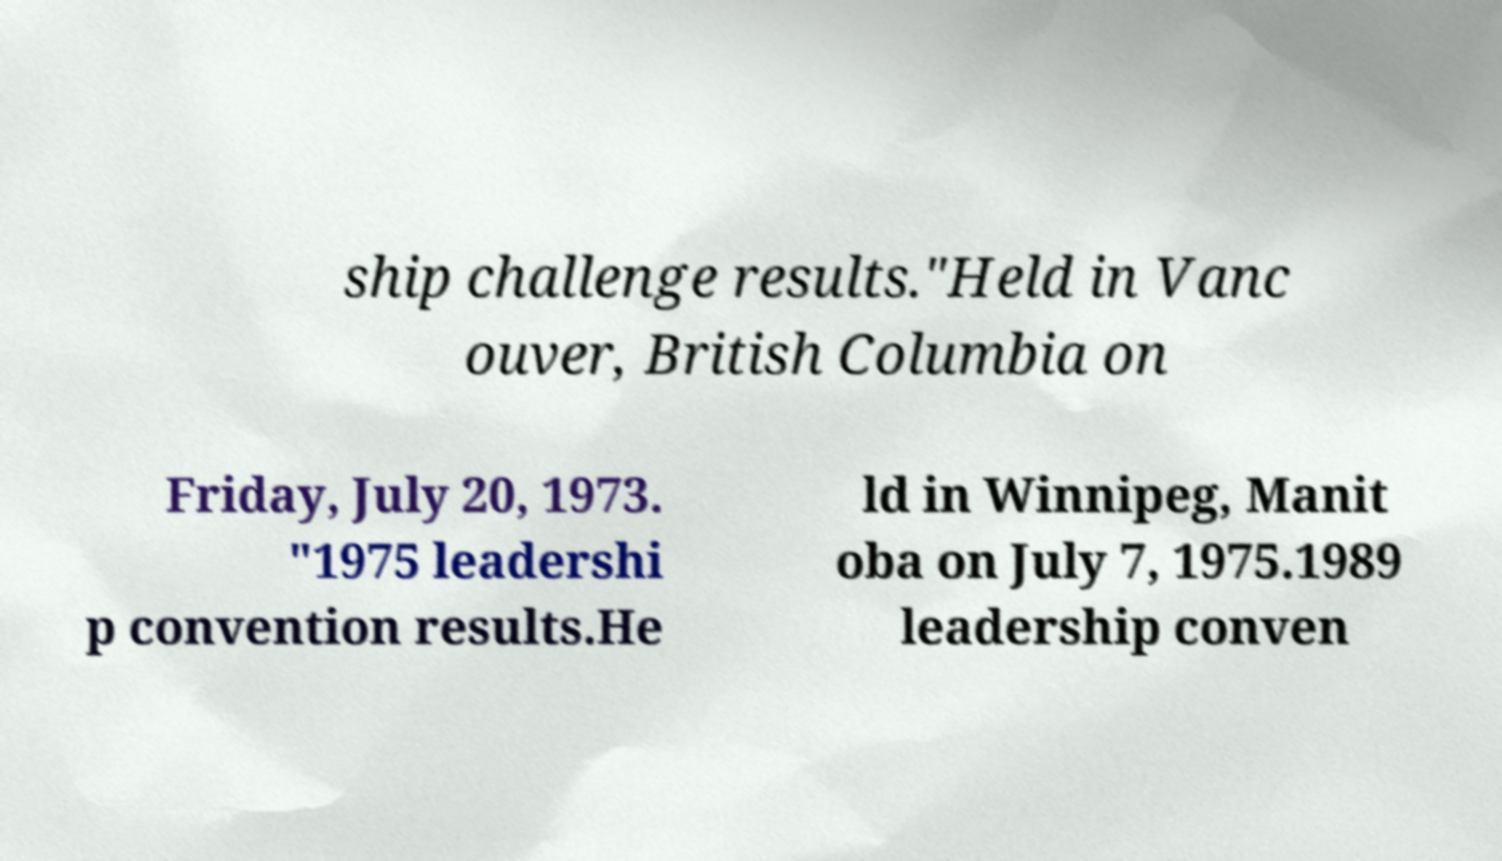I need the written content from this picture converted into text. Can you do that? ship challenge results."Held in Vanc ouver, British Columbia on Friday, July 20, 1973. "1975 leadershi p convention results.He ld in Winnipeg, Manit oba on July 7, 1975.1989 leadership conven 